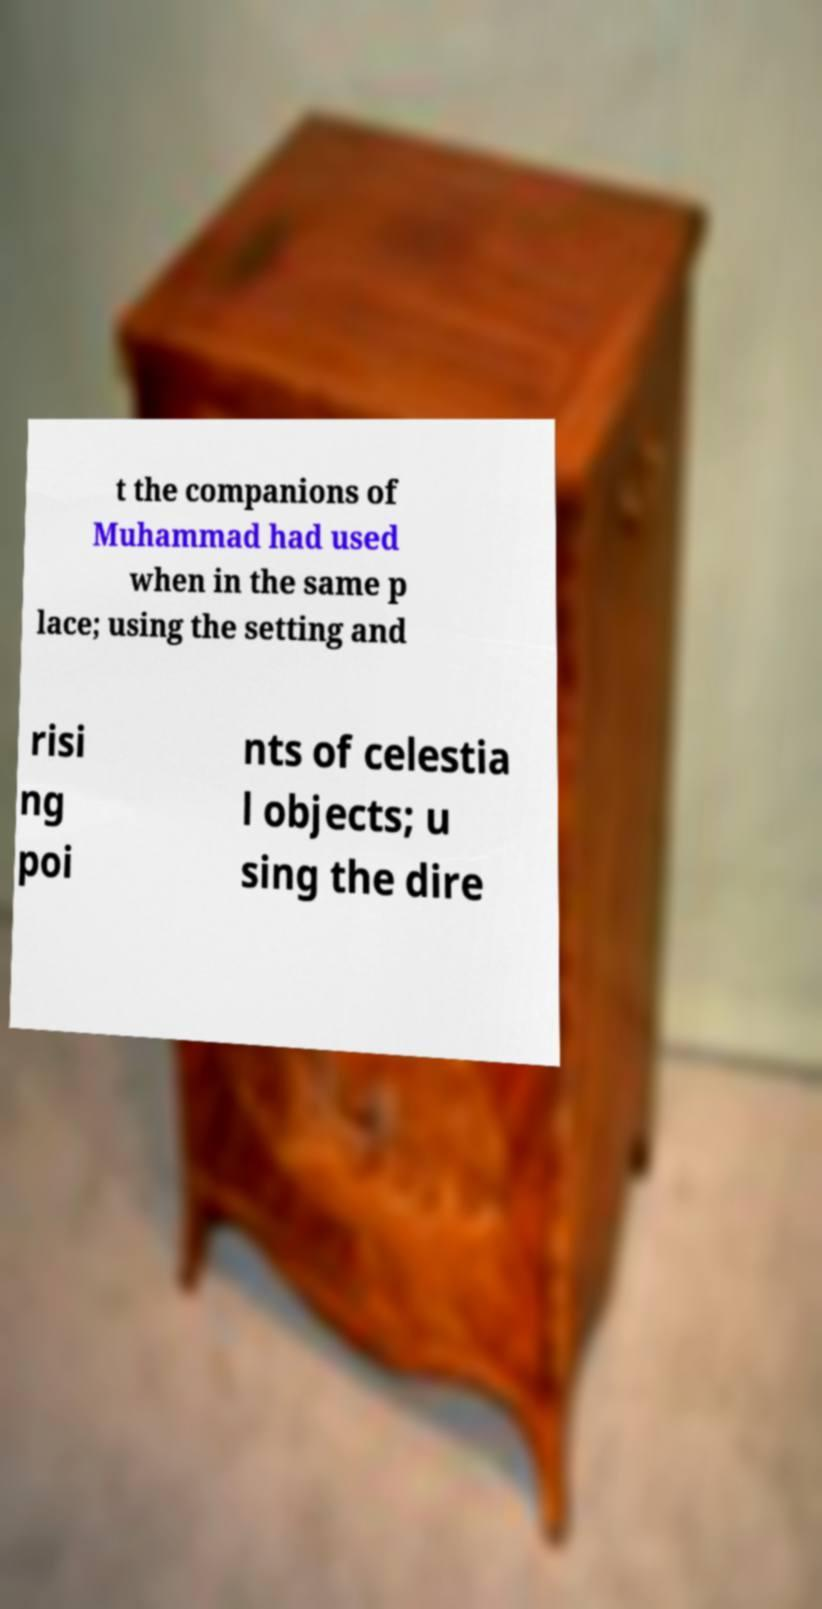For documentation purposes, I need the text within this image transcribed. Could you provide that? t the companions of Muhammad had used when in the same p lace; using the setting and risi ng poi nts of celestia l objects; u sing the dire 